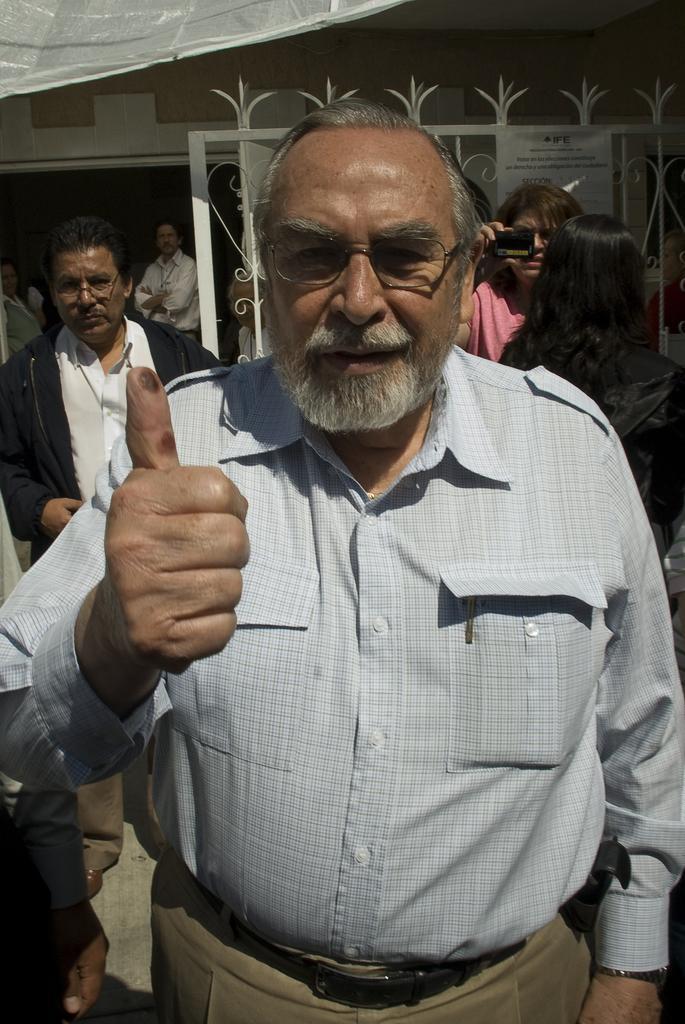Please provide a concise description of this image. In this image I can see few people standing and one person is holding camera. Back I can see a gate and building. 